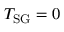Convert formula to latex. <formula><loc_0><loc_0><loc_500><loc_500>T _ { S G } = 0</formula> 